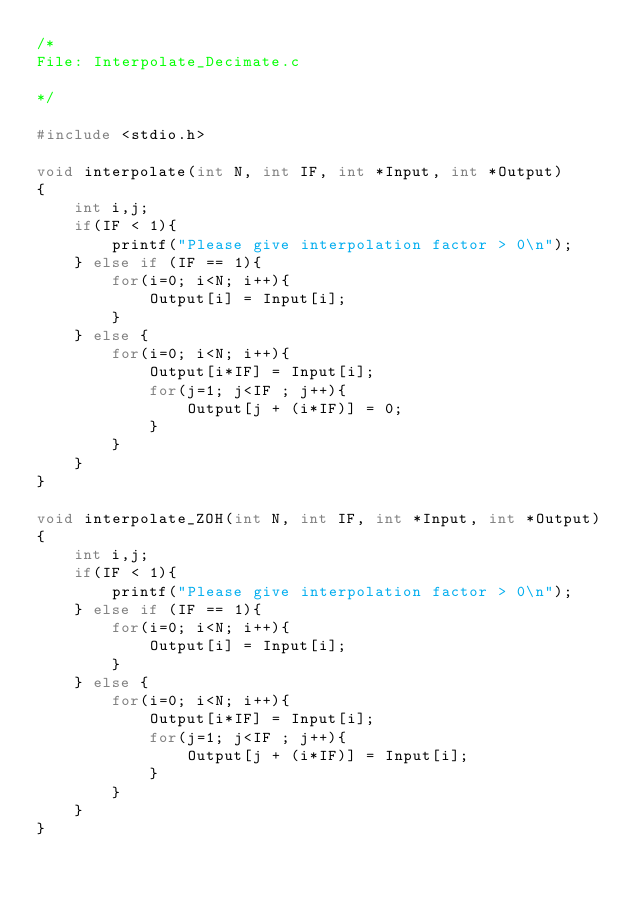<code> <loc_0><loc_0><loc_500><loc_500><_C_>/*
File: Interpolate_Decimate.c

*/

#include <stdio.h>

void interpolate(int N, int IF, int *Input, int *Output)
{
	int i,j;
	if(IF < 1){
		printf("Please give interpolation factor > 0\n");
	} else if (IF == 1){
		for(i=0; i<N; i++){
			Output[i] = Input[i];
		}
	} else {
		for(i=0; i<N; i++){
			Output[i*IF] = Input[i];
			for(j=1; j<IF ; j++){
				Output[j + (i*IF)] = 0;
			}
		}
	}
}

void interpolate_ZOH(int N, int IF, int *Input, int *Output)
{
	int i,j;
	if(IF < 1){
		printf("Please give interpolation factor > 0\n");
	} else if (IF == 1){
		for(i=0; i<N; i++){
			Output[i] = Input[i];
		}
	} else {
		for(i=0; i<N; i++){
			Output[i*IF] = Input[i];
			for(j=1; j<IF ; j++){
				Output[j + (i*IF)] = Input[i];
			}
		}
	}
}
</code> 